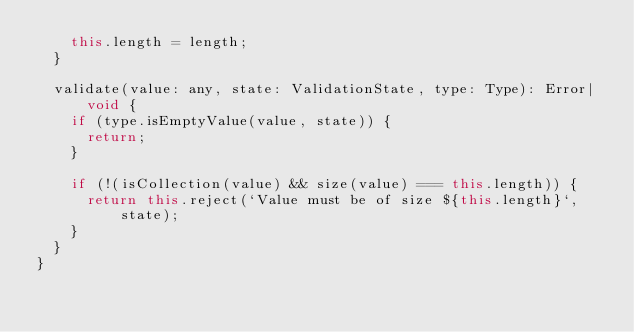Convert code to text. <code><loc_0><loc_0><loc_500><loc_500><_JavaScript_>    this.length = length;
  }

  validate(value: any, state: ValidationState, type: Type): Error|void {
    if (type.isEmptyValue(value, state)) {
      return;
    }

    if (!(isCollection(value) && size(value) === this.length)) {
      return this.reject(`Value must be of size ${this.length}`, state);
    }
  }
}
</code> 